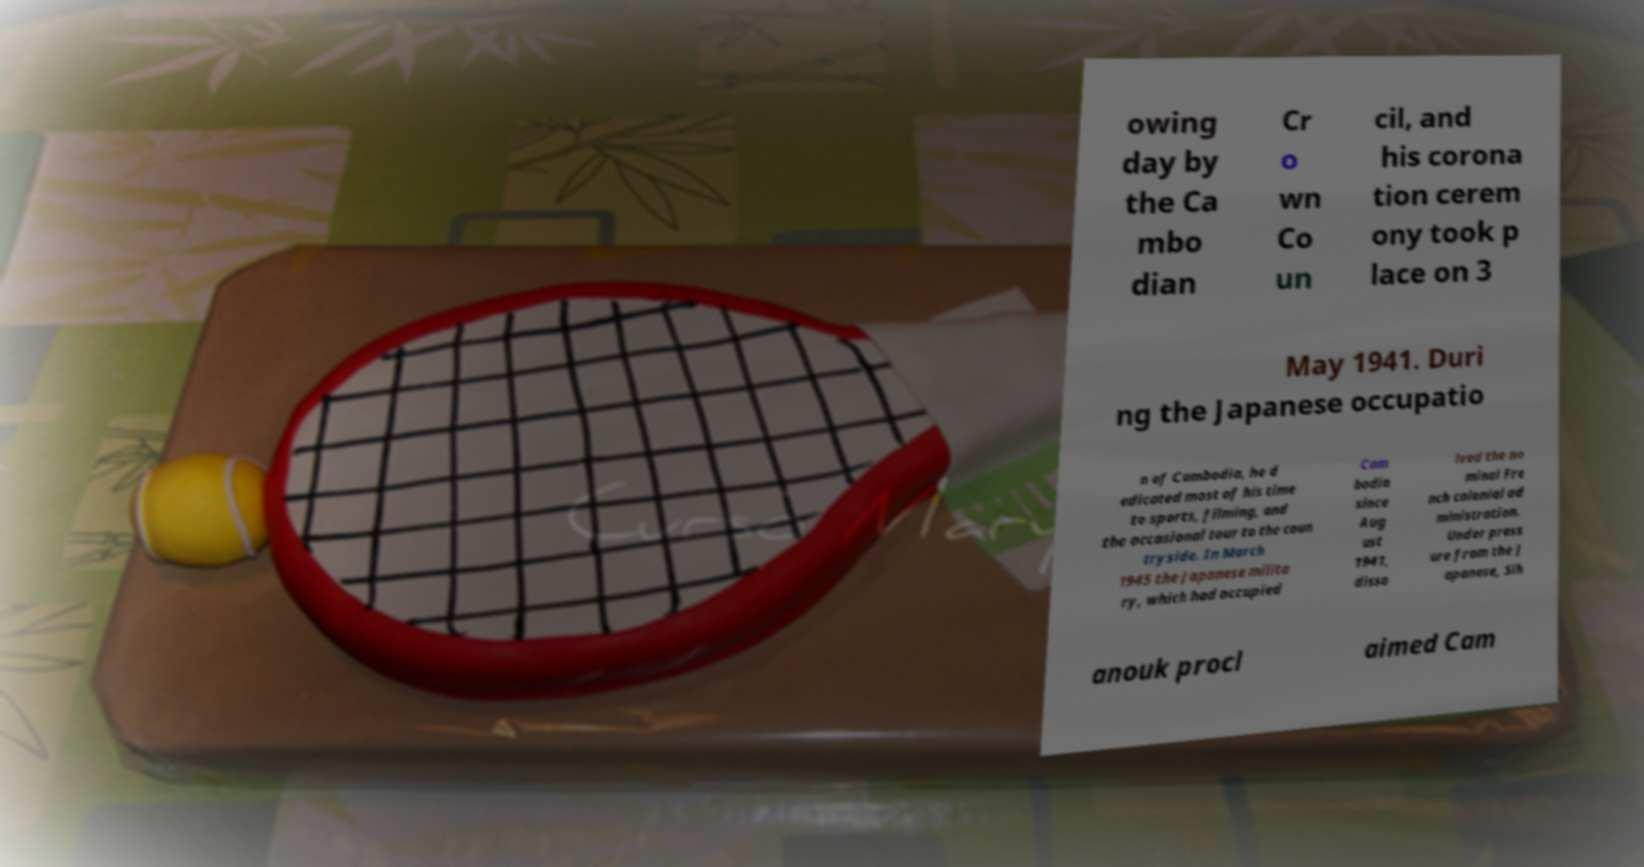Could you extract and type out the text from this image? owing day by the Ca mbo dian Cr o wn Co un cil, and his corona tion cerem ony took p lace on 3 May 1941. Duri ng the Japanese occupatio n of Cambodia, he d edicated most of his time to sports, filming, and the occasional tour to the coun tryside. In March 1945 the Japanese milita ry, which had occupied Cam bodia since Aug ust 1941, disso lved the no minal Fre nch colonial ad ministration. Under press ure from the J apanese, Sih anouk procl aimed Cam 